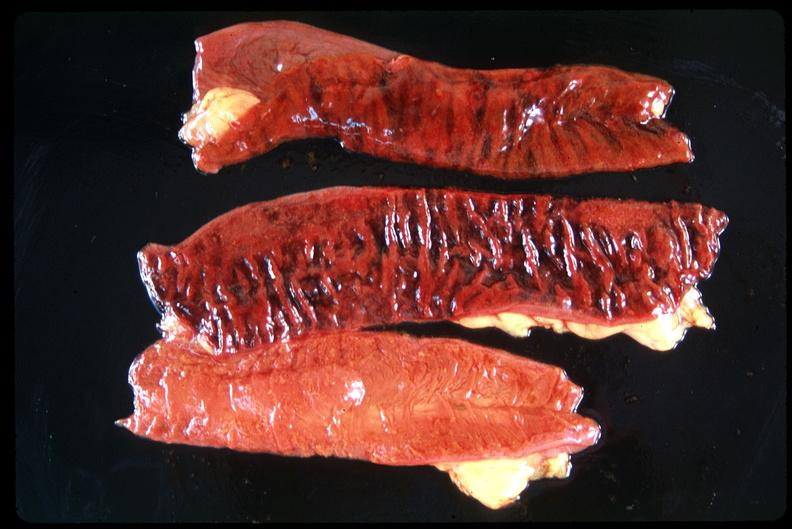s gastrointestinal present?
Answer the question using a single word or phrase. Yes 